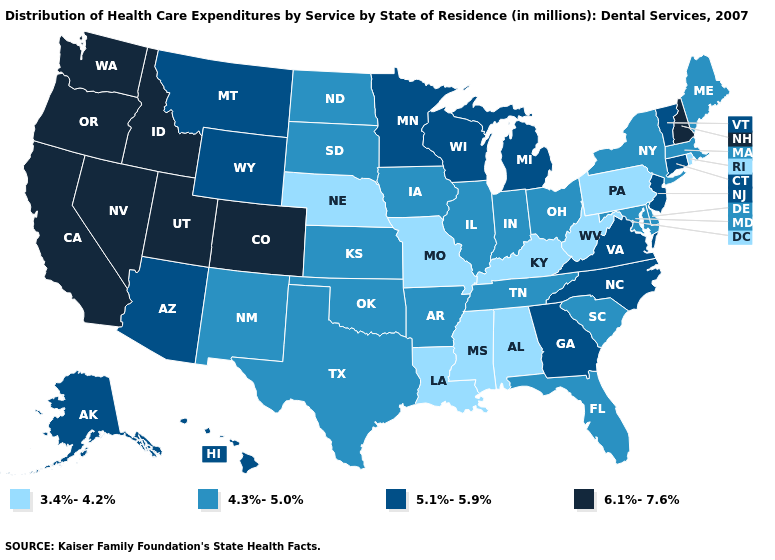Does Virginia have the lowest value in the USA?
Quick response, please. No. What is the value of Florida?
Be succinct. 4.3%-5.0%. Does Indiana have the highest value in the MidWest?
Answer briefly. No. Does Michigan have the highest value in the MidWest?
Short answer required. Yes. Does Minnesota have a lower value than California?
Be succinct. Yes. What is the value of Maryland?
Be succinct. 4.3%-5.0%. How many symbols are there in the legend?
Concise answer only. 4. Name the states that have a value in the range 5.1%-5.9%?
Keep it brief. Alaska, Arizona, Connecticut, Georgia, Hawaii, Michigan, Minnesota, Montana, New Jersey, North Carolina, Vermont, Virginia, Wisconsin, Wyoming. Name the states that have a value in the range 4.3%-5.0%?
Write a very short answer. Arkansas, Delaware, Florida, Illinois, Indiana, Iowa, Kansas, Maine, Maryland, Massachusetts, New Mexico, New York, North Dakota, Ohio, Oklahoma, South Carolina, South Dakota, Tennessee, Texas. Does Nebraska have the same value as Missouri?
Answer briefly. Yes. Does Mississippi have the lowest value in the South?
Be succinct. Yes. Name the states that have a value in the range 5.1%-5.9%?
Be succinct. Alaska, Arizona, Connecticut, Georgia, Hawaii, Michigan, Minnesota, Montana, New Jersey, North Carolina, Vermont, Virginia, Wisconsin, Wyoming. Name the states that have a value in the range 3.4%-4.2%?
Answer briefly. Alabama, Kentucky, Louisiana, Mississippi, Missouri, Nebraska, Pennsylvania, Rhode Island, West Virginia. What is the value of Oregon?
Concise answer only. 6.1%-7.6%. Name the states that have a value in the range 6.1%-7.6%?
Concise answer only. California, Colorado, Idaho, Nevada, New Hampshire, Oregon, Utah, Washington. 